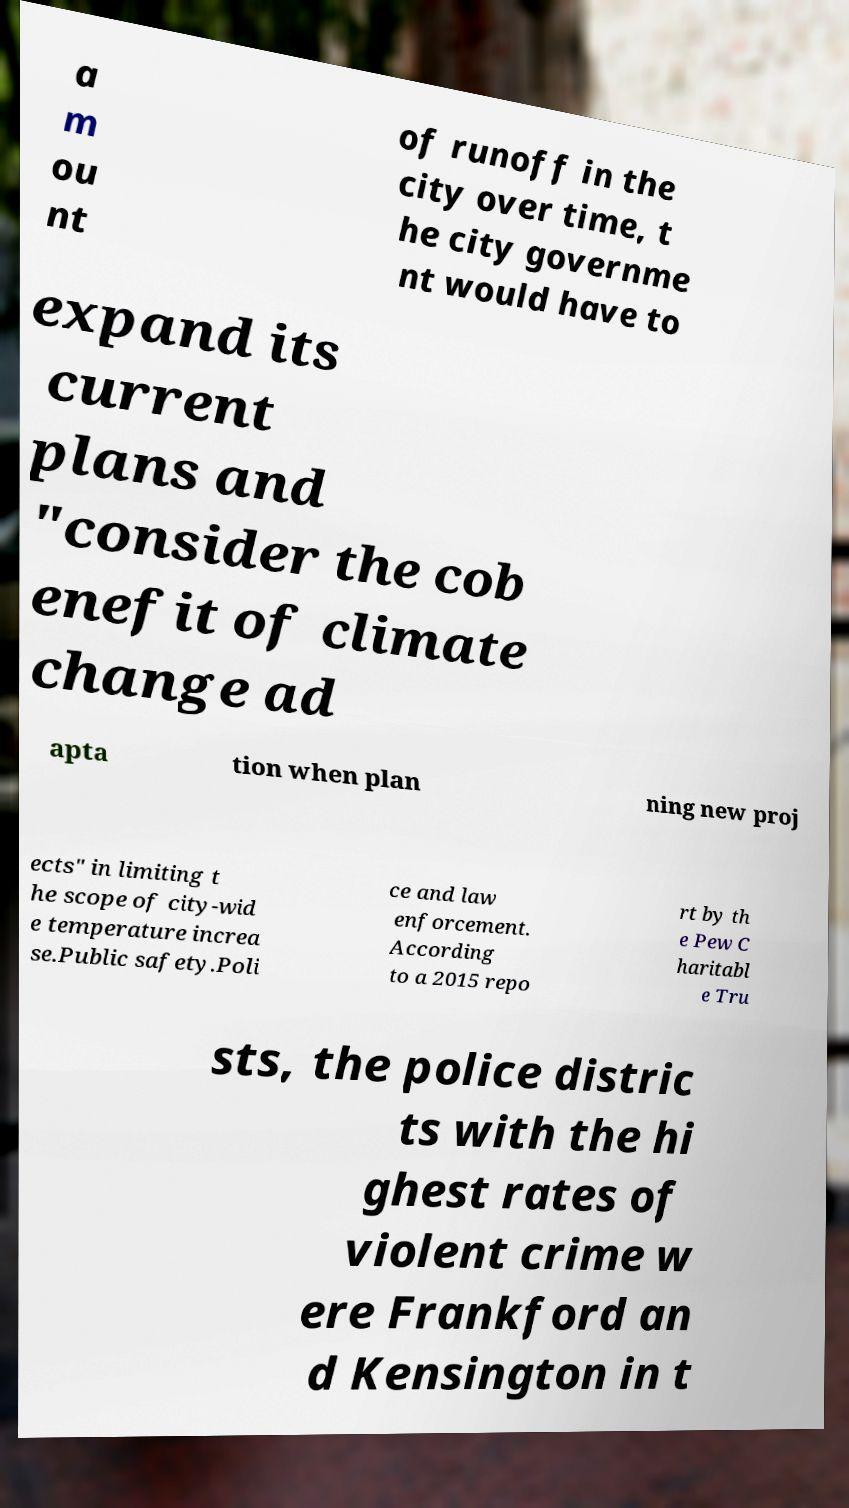What messages or text are displayed in this image? I need them in a readable, typed format. a m ou nt of runoff in the city over time, t he city governme nt would have to expand its current plans and "consider the cob enefit of climate change ad apta tion when plan ning new proj ects" in limiting t he scope of city-wid e temperature increa se.Public safety.Poli ce and law enforcement. According to a 2015 repo rt by th e Pew C haritabl e Tru sts, the police distric ts with the hi ghest rates of violent crime w ere Frankford an d Kensington in t 